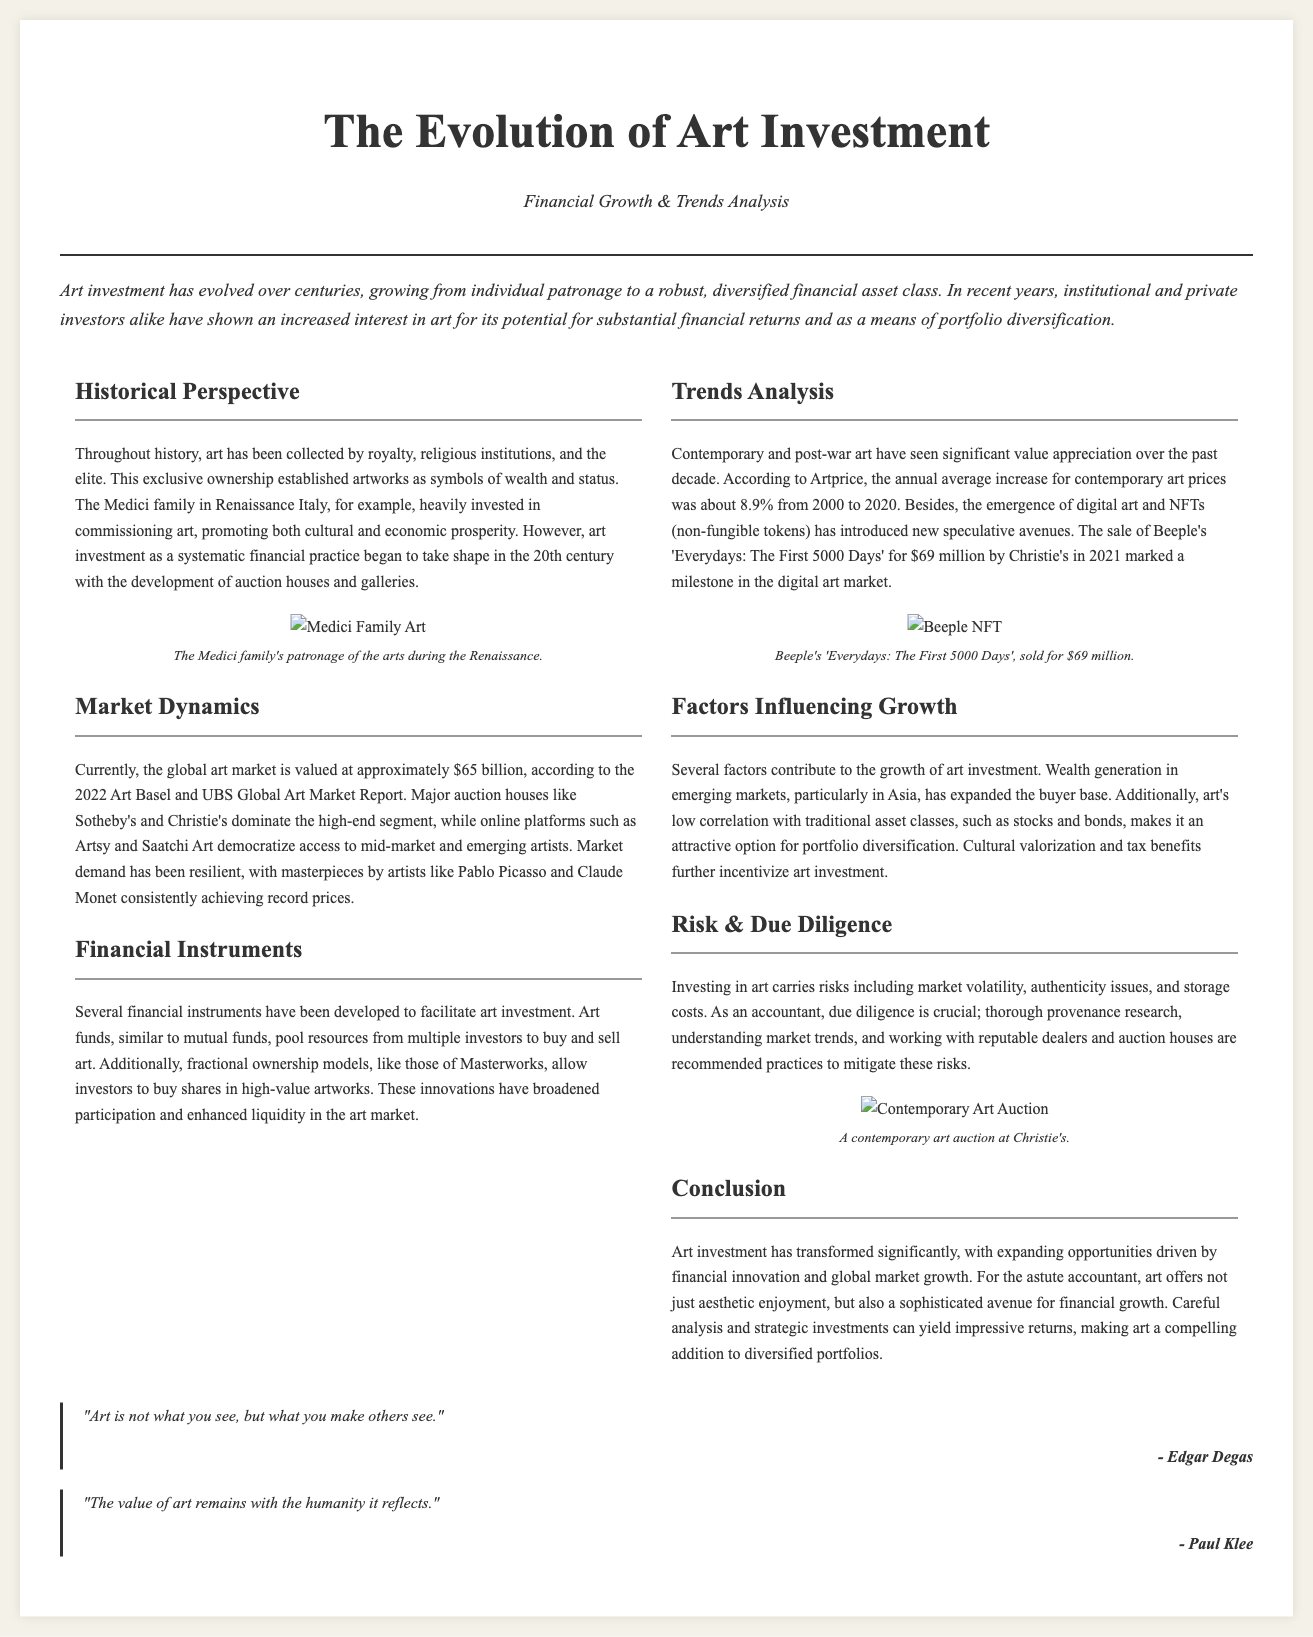what is the global art market value? The document states that the global art market is valued at approximately $65 billion according to the 2022 report.
Answer: $65 billion who sold the NFT 'Everydays: The First 5000 Days'? The document mentions that Christie's sold Beeple's 'Everydays: The First 5000 Days' for $69 million.
Answer: Christie's what was the average increase for contemporary art prices from 2000 to 2020? The document indicates that the annual average increase for contemporary art prices was about 8.9%.
Answer: 8.9% which family heavily invested in commissioning art during the Renaissance? The text refers to the Medici family, who were known for their patronage of the arts during that era.
Answer: Medici family what is a potential reason for the growth in art investment? The document lists wealth generation in emerging markets as a factor contributing to growth.
Answer: Wealth generation in emerging markets what financial instrument pools resources from multiple investors to buy and sell art? The text explains that art funds are designed to facilitate art investment by pooling resources.
Answer: Art funds how has the sale of digital art impacted the market? The document notes that the emergence of NFTs has introduced new speculative avenues in art investment.
Answer: New speculative avenues what is a crucial practice for mitigating risks in art investment? According to the document, thorough provenance research is recommended to mitigate risks.
Answer: Thorough provenance research 